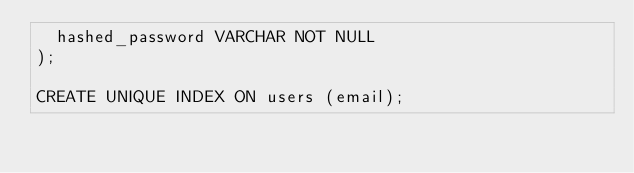<code> <loc_0><loc_0><loc_500><loc_500><_SQL_>  hashed_password VARCHAR NOT NULL
);

CREATE UNIQUE INDEX ON users (email);
</code> 